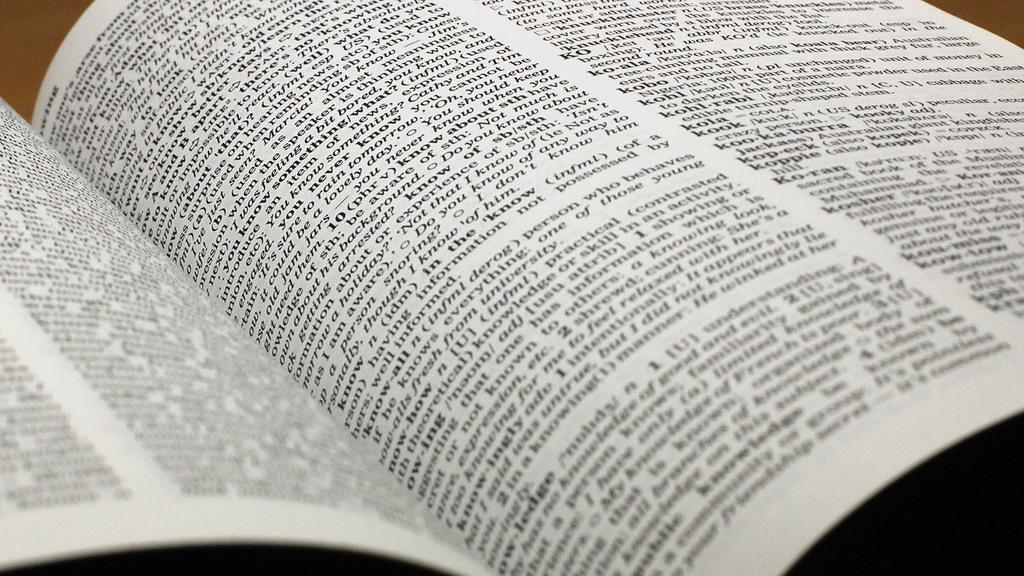Provide a one-sentence caption for the provided image. A dictionary is left open on a table. 